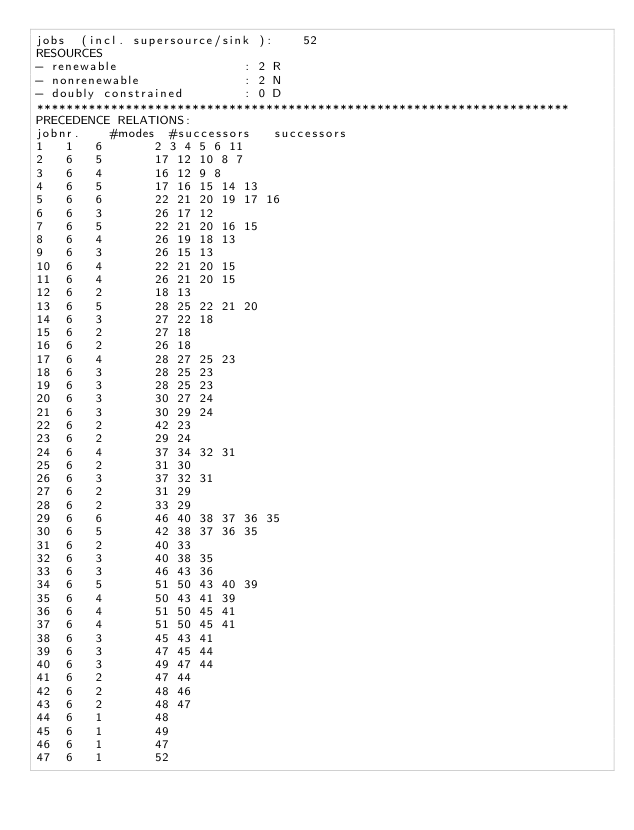<code> <loc_0><loc_0><loc_500><loc_500><_ObjectiveC_>jobs  (incl. supersource/sink ):	52
RESOURCES
- renewable                 : 2 R
- nonrenewable              : 2 N
- doubly constrained        : 0 D
************************************************************************
PRECEDENCE RELATIONS:
jobnr.    #modes  #successors   successors
1	1	6		2 3 4 5 6 11 
2	6	5		17 12 10 8 7 
3	6	4		16 12 9 8 
4	6	5		17 16 15 14 13 
5	6	6		22 21 20 19 17 16 
6	6	3		26 17 12 
7	6	5		22 21 20 16 15 
8	6	4		26 19 18 13 
9	6	3		26 15 13 
10	6	4		22 21 20 15 
11	6	4		26 21 20 15 
12	6	2		18 13 
13	6	5		28 25 22 21 20 
14	6	3		27 22 18 
15	6	2		27 18 
16	6	2		26 18 
17	6	4		28 27 25 23 
18	6	3		28 25 23 
19	6	3		28 25 23 
20	6	3		30 27 24 
21	6	3		30 29 24 
22	6	2		42 23 
23	6	2		29 24 
24	6	4		37 34 32 31 
25	6	2		31 30 
26	6	3		37 32 31 
27	6	2		31 29 
28	6	2		33 29 
29	6	6		46 40 38 37 36 35 
30	6	5		42 38 37 36 35 
31	6	2		40 33 
32	6	3		40 38 35 
33	6	3		46 43 36 
34	6	5		51 50 43 40 39 
35	6	4		50 43 41 39 
36	6	4		51 50 45 41 
37	6	4		51 50 45 41 
38	6	3		45 43 41 
39	6	3		47 45 44 
40	6	3		49 47 44 
41	6	2		47 44 
42	6	2		48 46 
43	6	2		48 47 
44	6	1		48 
45	6	1		49 
46	6	1		47 
47	6	1		52 </code> 